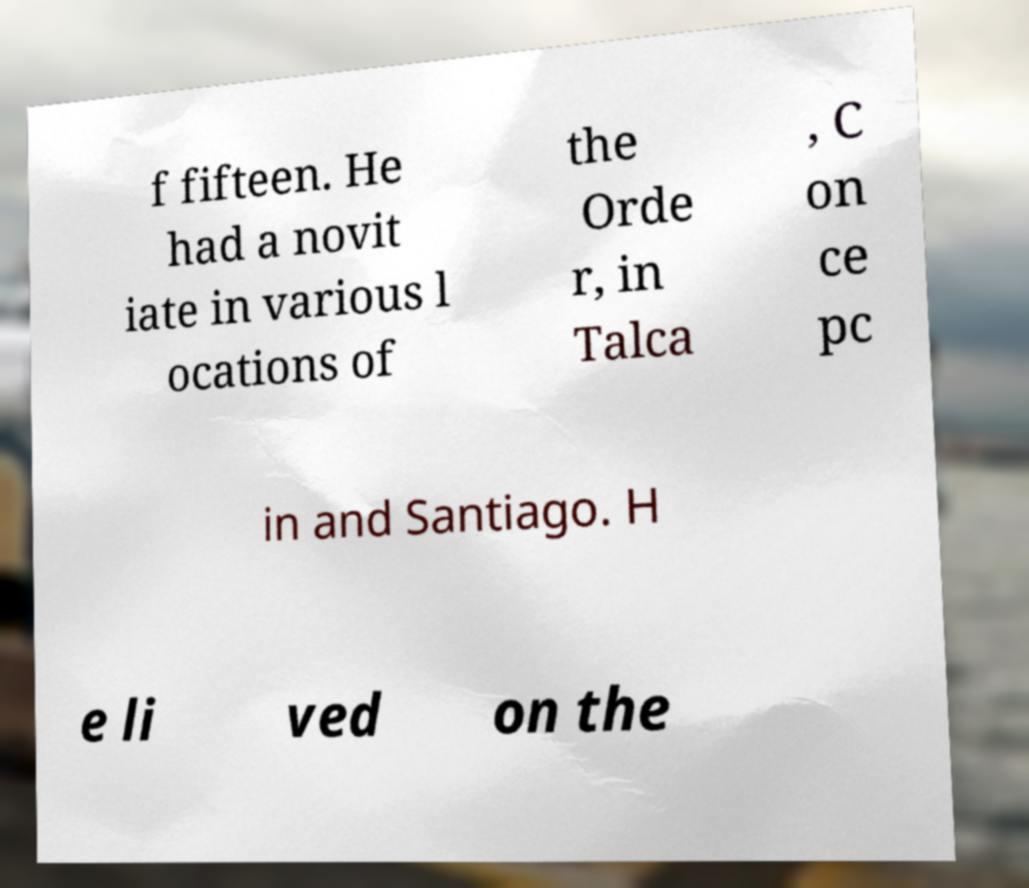I need the written content from this picture converted into text. Can you do that? f fifteen. He had a novit iate in various l ocations of the Orde r, in Talca , C on ce pc in and Santiago. H e li ved on the 